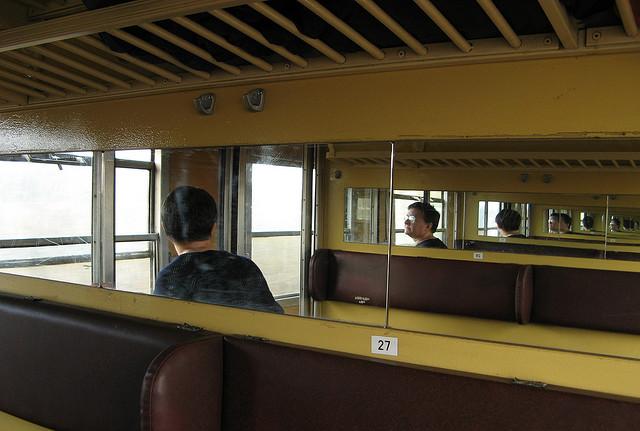What is reflecting?
Concise answer only. Man. Why is the number 27 on the wall?
Short answer required. Seat number. How many people are sitting at tables in this room?
Concise answer only. 1. How many coat hangers are there?
Give a very brief answer. 0. 